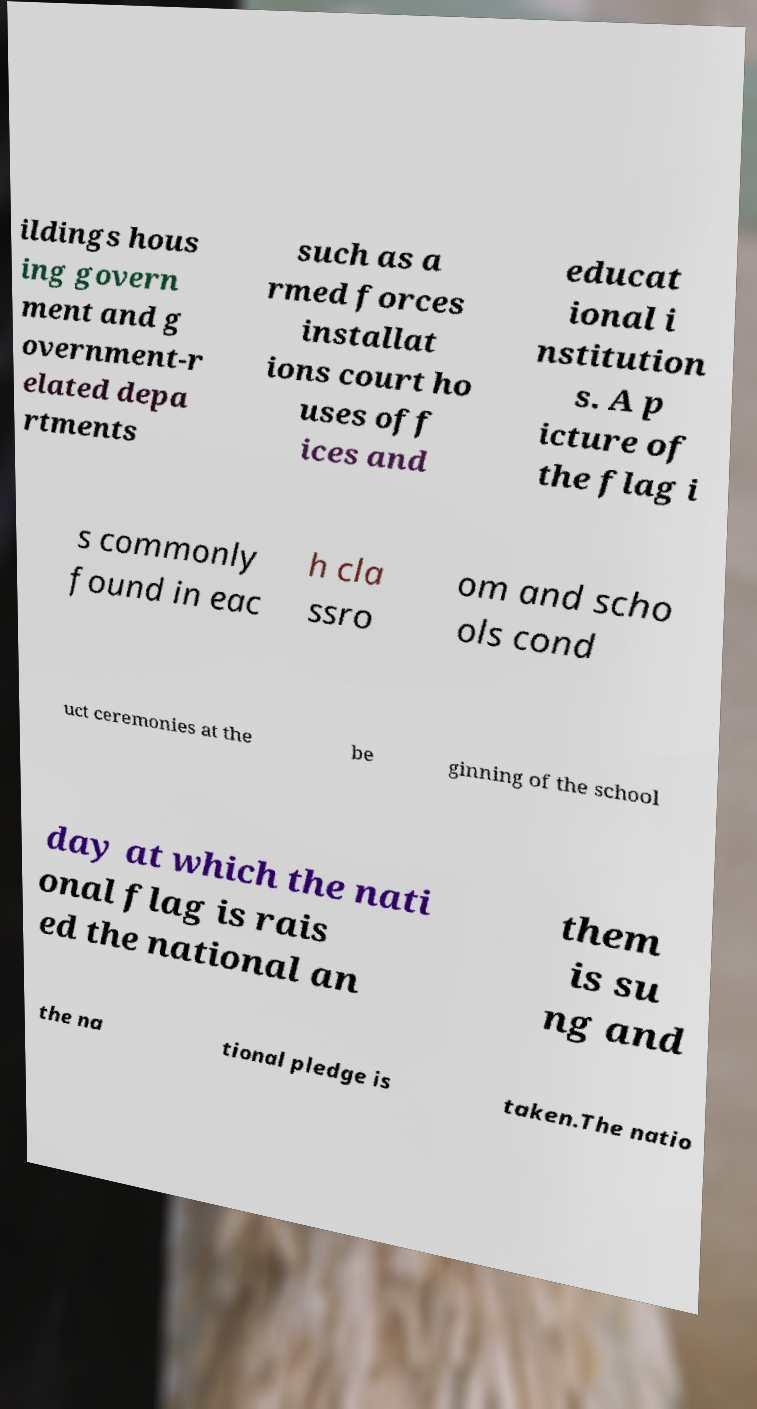There's text embedded in this image that I need extracted. Can you transcribe it verbatim? ildings hous ing govern ment and g overnment-r elated depa rtments such as a rmed forces installat ions court ho uses off ices and educat ional i nstitution s. A p icture of the flag i s commonly found in eac h cla ssro om and scho ols cond uct ceremonies at the be ginning of the school day at which the nati onal flag is rais ed the national an them is su ng and the na tional pledge is taken.The natio 